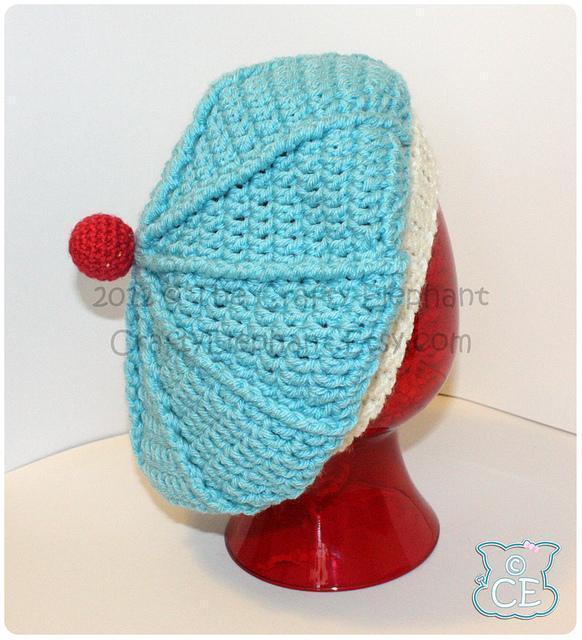How many animals are in the picture?
Give a very brief answer. 0. 